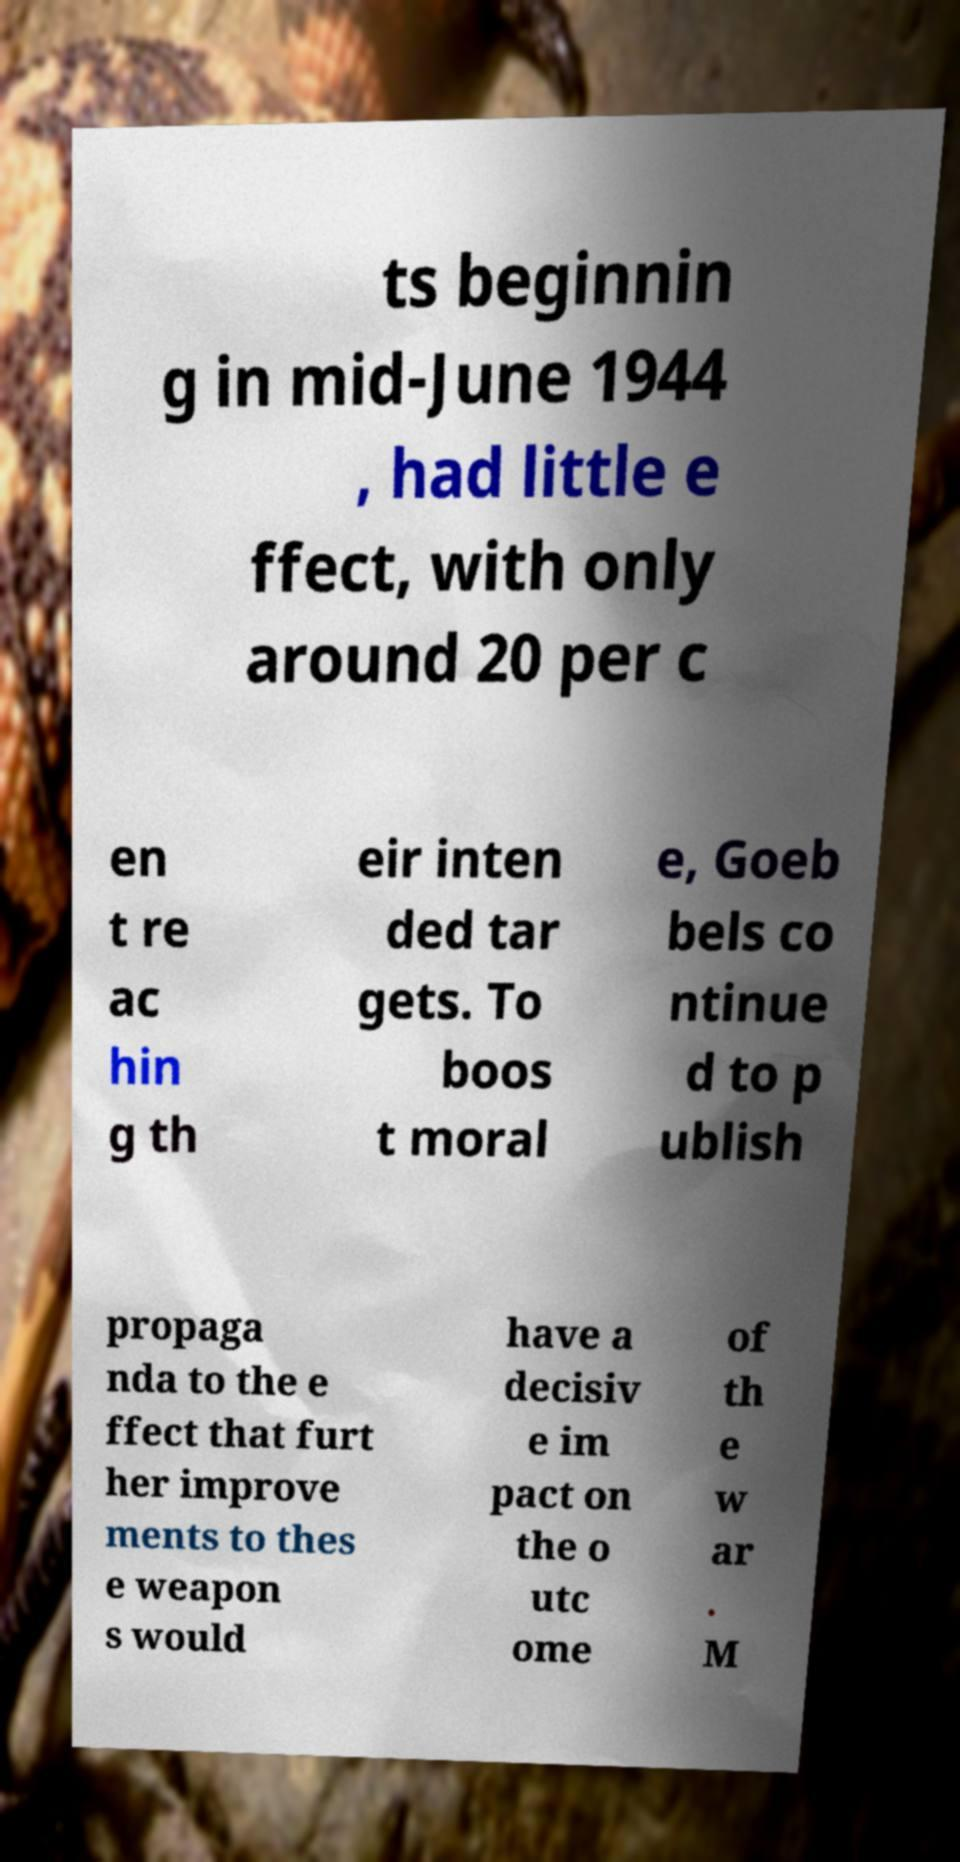Please identify and transcribe the text found in this image. ts beginnin g in mid-June 1944 , had little e ffect, with only around 20 per c en t re ac hin g th eir inten ded tar gets. To boos t moral e, Goeb bels co ntinue d to p ublish propaga nda to the e ffect that furt her improve ments to thes e weapon s would have a decisiv e im pact on the o utc ome of th e w ar . M 